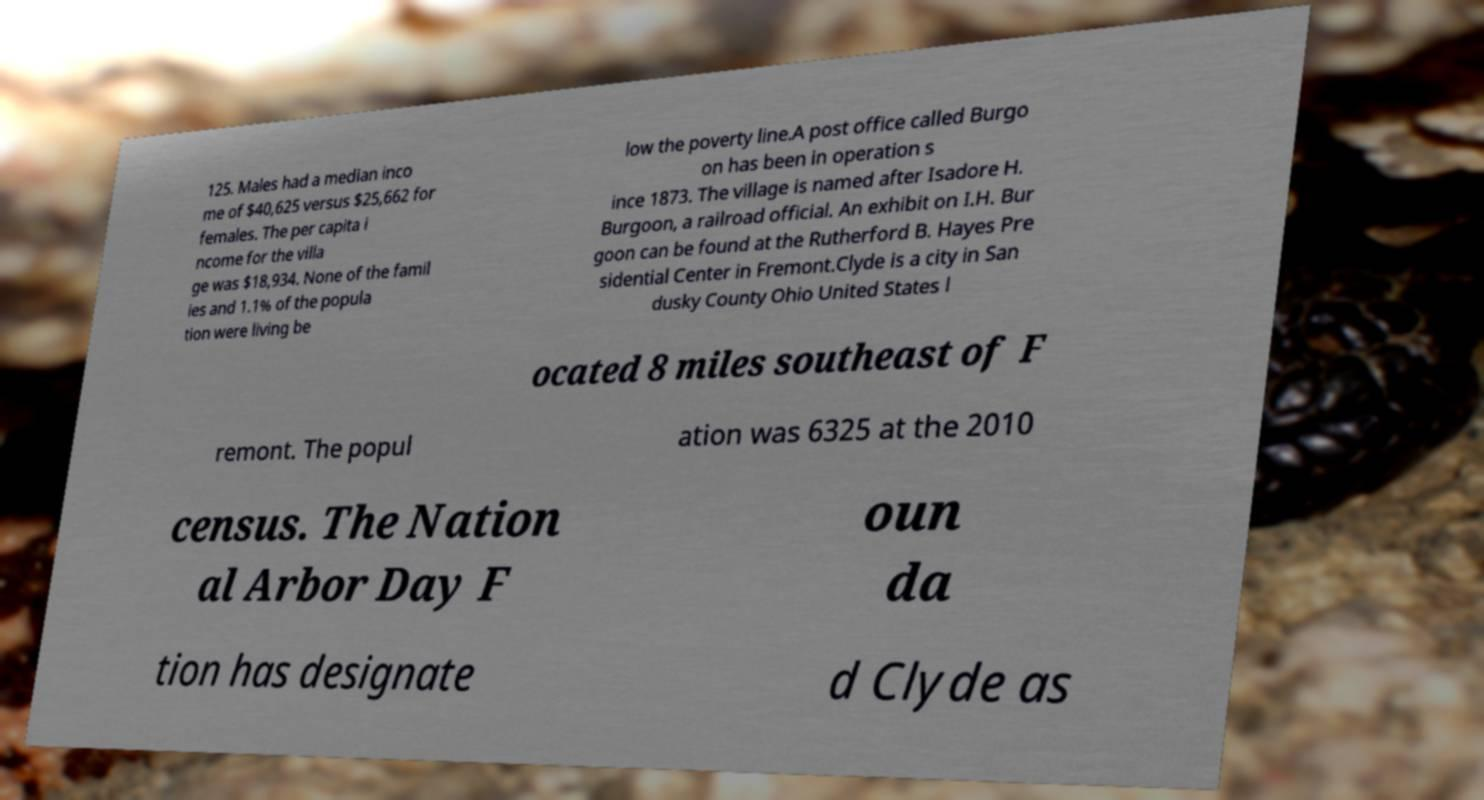Can you read and provide the text displayed in the image?This photo seems to have some interesting text. Can you extract and type it out for me? 125. Males had a median inco me of $40,625 versus $25,662 for females. The per capita i ncome for the villa ge was $18,934. None of the famil ies and 1.1% of the popula tion were living be low the poverty line.A post office called Burgo on has been in operation s ince 1873. The village is named after Isadore H. Burgoon, a railroad official. An exhibit on I.H. Bur goon can be found at the Rutherford B. Hayes Pre sidential Center in Fremont.Clyde is a city in San dusky County Ohio United States l ocated 8 miles southeast of F remont. The popul ation was 6325 at the 2010 census. The Nation al Arbor Day F oun da tion has designate d Clyde as 